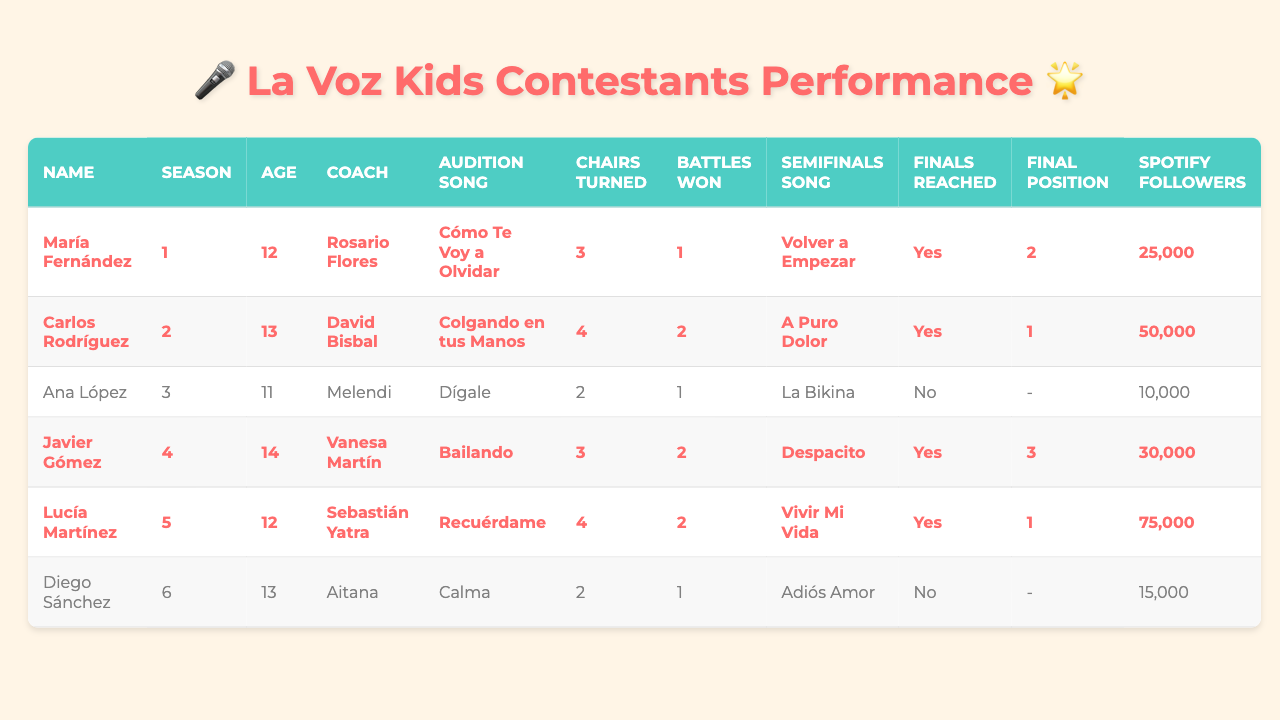What is the audition song of María Fernández? According to the table, María Fernández auditioned with the song "Cómo Te Voy a Olvidar."
Answer: Cómo Te Voy a Olvidar Which coach did Lucía Martínez have? The table specifies that Lucía Martínez was coached by Sebastián Yatra.
Answer: Sebastián Yatra How many chairs did Carlos Rodríguez turn during his audition? Carlos Rodríguez turned 4 chairs during his audition, as noted in the table.
Answer: 4 chairs Did Javier Gómez reach the finals? From the table, it is clear that Javier Gómez did reach the finals, as indicated in the "Finals Reached" column.
Answer: Yes What is the final position of the contestant who won the most battles? The contestant who won the most battles is Lucía Martínez with 2 battles won, and she reached the finals, placing 1st.
Answer: 1 Which contestant has the highest number of Spotify followers post-show? The table shows that Lucía Martínez has the highest number of Spotify followers post-show with a total of 75,000.
Answer: 75,000 followers What is the age of the contestant who finished in 2nd place? María Fernández finished in 2nd place and her age is listed as 12 in the table.
Answer: 12 How many contestants reached the finals but did not win? The table lists two contestants—Javier Gómez (3rd place) and María Fernández (2nd place)—who reached the finals but did not win.
Answer: 2 contestants Which contestant had the least number of Spotify followers? Ana López had the least number of Spotify followers post-show, with a total of 10,000, as indicated in the table.
Answer: 10,000 followers What is the average age of the contestants who reached the finals? The contestants who reached the finals are María Fernández (12), Carlos Rodríguez (13), Javier Gómez (14), and Lucía Martínez (12). The average age is calculated as (12 + 13 + 14 + 12) / 4 = 12.75.
Answer: 12.75 years How many auditions involved 3 chairs turned? The table shows that María Fernández and Javier Gómez each had 3 chairs turned during their auditions. Thus, there are 2 contestants with 3 chairs.
Answer: 2 contestants What performances did contestants sing in the semifinals? The semifinal performances include "Volver a Empezar" (María Fernández), "A Puro Dolor" (Carlos Rodríguez), "La Bikina" (Ana López), "Despacito" (Javier Gómez), and "Vivir Mi Vida" (Lucía Martínez).
Answer: 5 performances 